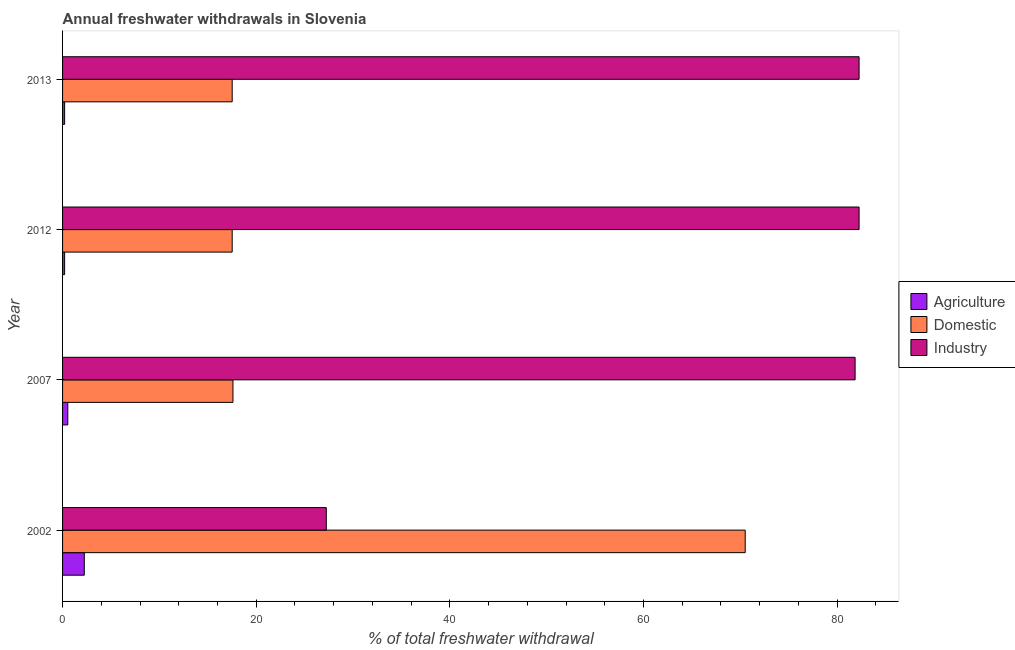How many groups of bars are there?
Offer a terse response. 4. Are the number of bars on each tick of the Y-axis equal?
Offer a very short reply. Yes. How many bars are there on the 3rd tick from the top?
Give a very brief answer. 3. What is the label of the 4th group of bars from the top?
Ensure brevity in your answer.  2002. In how many cases, is the number of bars for a given year not equal to the number of legend labels?
Your response must be concise. 0. What is the percentage of freshwater withdrawal for agriculture in 2013?
Ensure brevity in your answer.  0.21. Across all years, what is the maximum percentage of freshwater withdrawal for agriculture?
Make the answer very short. 2.24. Across all years, what is the minimum percentage of freshwater withdrawal for agriculture?
Offer a terse response. 0.21. In which year was the percentage of freshwater withdrawal for industry minimum?
Make the answer very short. 2002. What is the total percentage of freshwater withdrawal for domestic purposes in the graph?
Your answer should be compact. 123.15. What is the difference between the percentage of freshwater withdrawal for domestic purposes in 2002 and that in 2012?
Keep it short and to the point. 52.99. What is the difference between the percentage of freshwater withdrawal for domestic purposes in 2013 and the percentage of freshwater withdrawal for industry in 2012?
Keep it short and to the point. -64.75. What is the average percentage of freshwater withdrawal for agriculture per year?
Keep it short and to the point. 0.8. In the year 2002, what is the difference between the percentage of freshwater withdrawal for domestic purposes and percentage of freshwater withdrawal for industry?
Your answer should be very brief. 43.27. In how many years, is the percentage of freshwater withdrawal for agriculture greater than 20 %?
Keep it short and to the point. 0. What is the ratio of the percentage of freshwater withdrawal for agriculture in 2002 to that in 2012?
Your response must be concise. 10.57. What is the difference between the highest and the second highest percentage of freshwater withdrawal for domestic purposes?
Ensure brevity in your answer.  52.91. What is the difference between the highest and the lowest percentage of freshwater withdrawal for industry?
Offer a terse response. 55.03. In how many years, is the percentage of freshwater withdrawal for industry greater than the average percentage of freshwater withdrawal for industry taken over all years?
Keep it short and to the point. 3. Is the sum of the percentage of freshwater withdrawal for agriculture in 2007 and 2013 greater than the maximum percentage of freshwater withdrawal for industry across all years?
Provide a short and direct response. No. What does the 2nd bar from the top in 2013 represents?
Give a very brief answer. Domestic. What does the 1st bar from the bottom in 2013 represents?
Your answer should be compact. Agriculture. What is the difference between two consecutive major ticks on the X-axis?
Offer a terse response. 20. Are the values on the major ticks of X-axis written in scientific E-notation?
Your answer should be compact. No. Does the graph contain any zero values?
Offer a terse response. No. How are the legend labels stacked?
Your answer should be compact. Vertical. What is the title of the graph?
Ensure brevity in your answer.  Annual freshwater withdrawals in Slovenia. What is the label or title of the X-axis?
Your response must be concise. % of total freshwater withdrawal. What is the label or title of the Y-axis?
Give a very brief answer. Year. What is the % of total freshwater withdrawal in Agriculture in 2002?
Provide a short and direct response. 2.24. What is the % of total freshwater withdrawal in Domestic in 2002?
Ensure brevity in your answer.  70.51. What is the % of total freshwater withdrawal in Industry in 2002?
Keep it short and to the point. 27.24. What is the % of total freshwater withdrawal in Agriculture in 2007?
Your answer should be very brief. 0.54. What is the % of total freshwater withdrawal in Industry in 2007?
Your response must be concise. 81.86. What is the % of total freshwater withdrawal in Agriculture in 2012?
Make the answer very short. 0.21. What is the % of total freshwater withdrawal in Domestic in 2012?
Provide a succinct answer. 17.52. What is the % of total freshwater withdrawal in Industry in 2012?
Your answer should be very brief. 82.27. What is the % of total freshwater withdrawal in Agriculture in 2013?
Provide a succinct answer. 0.21. What is the % of total freshwater withdrawal of Domestic in 2013?
Offer a terse response. 17.52. What is the % of total freshwater withdrawal in Industry in 2013?
Keep it short and to the point. 82.27. Across all years, what is the maximum % of total freshwater withdrawal of Agriculture?
Provide a short and direct response. 2.24. Across all years, what is the maximum % of total freshwater withdrawal of Domestic?
Offer a terse response. 70.51. Across all years, what is the maximum % of total freshwater withdrawal of Industry?
Provide a short and direct response. 82.27. Across all years, what is the minimum % of total freshwater withdrawal of Agriculture?
Provide a succinct answer. 0.21. Across all years, what is the minimum % of total freshwater withdrawal of Domestic?
Provide a short and direct response. 17.52. Across all years, what is the minimum % of total freshwater withdrawal of Industry?
Give a very brief answer. 27.24. What is the total % of total freshwater withdrawal of Agriculture in the graph?
Offer a very short reply. 3.21. What is the total % of total freshwater withdrawal of Domestic in the graph?
Your response must be concise. 123.15. What is the total % of total freshwater withdrawal of Industry in the graph?
Offer a terse response. 273.64. What is the difference between the % of total freshwater withdrawal in Agriculture in 2002 and that in 2007?
Your response must be concise. 1.7. What is the difference between the % of total freshwater withdrawal in Domestic in 2002 and that in 2007?
Keep it short and to the point. 52.91. What is the difference between the % of total freshwater withdrawal in Industry in 2002 and that in 2007?
Make the answer very short. -54.62. What is the difference between the % of total freshwater withdrawal in Agriculture in 2002 and that in 2012?
Make the answer very short. 2.03. What is the difference between the % of total freshwater withdrawal in Domestic in 2002 and that in 2012?
Provide a short and direct response. 52.99. What is the difference between the % of total freshwater withdrawal of Industry in 2002 and that in 2012?
Offer a very short reply. -55.03. What is the difference between the % of total freshwater withdrawal of Agriculture in 2002 and that in 2013?
Ensure brevity in your answer.  2.03. What is the difference between the % of total freshwater withdrawal of Domestic in 2002 and that in 2013?
Ensure brevity in your answer.  52.99. What is the difference between the % of total freshwater withdrawal of Industry in 2002 and that in 2013?
Keep it short and to the point. -55.03. What is the difference between the % of total freshwater withdrawal of Agriculture in 2007 and that in 2012?
Ensure brevity in your answer.  0.33. What is the difference between the % of total freshwater withdrawal of Industry in 2007 and that in 2012?
Ensure brevity in your answer.  -0.41. What is the difference between the % of total freshwater withdrawal in Agriculture in 2007 and that in 2013?
Your response must be concise. 0.33. What is the difference between the % of total freshwater withdrawal of Industry in 2007 and that in 2013?
Your response must be concise. -0.41. What is the difference between the % of total freshwater withdrawal of Agriculture in 2012 and that in 2013?
Your response must be concise. 0. What is the difference between the % of total freshwater withdrawal in Industry in 2012 and that in 2013?
Your response must be concise. 0. What is the difference between the % of total freshwater withdrawal of Agriculture in 2002 and the % of total freshwater withdrawal of Domestic in 2007?
Provide a short and direct response. -15.36. What is the difference between the % of total freshwater withdrawal in Agriculture in 2002 and the % of total freshwater withdrawal in Industry in 2007?
Keep it short and to the point. -79.62. What is the difference between the % of total freshwater withdrawal of Domestic in 2002 and the % of total freshwater withdrawal of Industry in 2007?
Provide a short and direct response. -11.35. What is the difference between the % of total freshwater withdrawal in Agriculture in 2002 and the % of total freshwater withdrawal in Domestic in 2012?
Give a very brief answer. -15.28. What is the difference between the % of total freshwater withdrawal of Agriculture in 2002 and the % of total freshwater withdrawal of Industry in 2012?
Keep it short and to the point. -80.03. What is the difference between the % of total freshwater withdrawal of Domestic in 2002 and the % of total freshwater withdrawal of Industry in 2012?
Ensure brevity in your answer.  -11.76. What is the difference between the % of total freshwater withdrawal in Agriculture in 2002 and the % of total freshwater withdrawal in Domestic in 2013?
Provide a succinct answer. -15.28. What is the difference between the % of total freshwater withdrawal of Agriculture in 2002 and the % of total freshwater withdrawal of Industry in 2013?
Keep it short and to the point. -80.03. What is the difference between the % of total freshwater withdrawal of Domestic in 2002 and the % of total freshwater withdrawal of Industry in 2013?
Your response must be concise. -11.76. What is the difference between the % of total freshwater withdrawal of Agriculture in 2007 and the % of total freshwater withdrawal of Domestic in 2012?
Your answer should be very brief. -16.98. What is the difference between the % of total freshwater withdrawal of Agriculture in 2007 and the % of total freshwater withdrawal of Industry in 2012?
Your answer should be very brief. -81.73. What is the difference between the % of total freshwater withdrawal of Domestic in 2007 and the % of total freshwater withdrawal of Industry in 2012?
Your response must be concise. -64.67. What is the difference between the % of total freshwater withdrawal in Agriculture in 2007 and the % of total freshwater withdrawal in Domestic in 2013?
Offer a terse response. -16.98. What is the difference between the % of total freshwater withdrawal in Agriculture in 2007 and the % of total freshwater withdrawal in Industry in 2013?
Offer a terse response. -81.73. What is the difference between the % of total freshwater withdrawal of Domestic in 2007 and the % of total freshwater withdrawal of Industry in 2013?
Your response must be concise. -64.67. What is the difference between the % of total freshwater withdrawal in Agriculture in 2012 and the % of total freshwater withdrawal in Domestic in 2013?
Ensure brevity in your answer.  -17.31. What is the difference between the % of total freshwater withdrawal in Agriculture in 2012 and the % of total freshwater withdrawal in Industry in 2013?
Make the answer very short. -82.06. What is the difference between the % of total freshwater withdrawal of Domestic in 2012 and the % of total freshwater withdrawal of Industry in 2013?
Your answer should be very brief. -64.75. What is the average % of total freshwater withdrawal of Agriculture per year?
Keep it short and to the point. 0.8. What is the average % of total freshwater withdrawal in Domestic per year?
Offer a terse response. 30.79. What is the average % of total freshwater withdrawal in Industry per year?
Your answer should be very brief. 68.41. In the year 2002, what is the difference between the % of total freshwater withdrawal of Agriculture and % of total freshwater withdrawal of Domestic?
Provide a succinct answer. -68.27. In the year 2002, what is the difference between the % of total freshwater withdrawal of Agriculture and % of total freshwater withdrawal of Industry?
Keep it short and to the point. -25. In the year 2002, what is the difference between the % of total freshwater withdrawal in Domestic and % of total freshwater withdrawal in Industry?
Provide a short and direct response. 43.27. In the year 2007, what is the difference between the % of total freshwater withdrawal of Agriculture and % of total freshwater withdrawal of Domestic?
Provide a short and direct response. -17.06. In the year 2007, what is the difference between the % of total freshwater withdrawal of Agriculture and % of total freshwater withdrawal of Industry?
Your response must be concise. -81.32. In the year 2007, what is the difference between the % of total freshwater withdrawal of Domestic and % of total freshwater withdrawal of Industry?
Make the answer very short. -64.26. In the year 2012, what is the difference between the % of total freshwater withdrawal in Agriculture and % of total freshwater withdrawal in Domestic?
Provide a short and direct response. -17.31. In the year 2012, what is the difference between the % of total freshwater withdrawal of Agriculture and % of total freshwater withdrawal of Industry?
Ensure brevity in your answer.  -82.06. In the year 2012, what is the difference between the % of total freshwater withdrawal in Domestic and % of total freshwater withdrawal in Industry?
Your response must be concise. -64.75. In the year 2013, what is the difference between the % of total freshwater withdrawal of Agriculture and % of total freshwater withdrawal of Domestic?
Ensure brevity in your answer.  -17.31. In the year 2013, what is the difference between the % of total freshwater withdrawal of Agriculture and % of total freshwater withdrawal of Industry?
Give a very brief answer. -82.06. In the year 2013, what is the difference between the % of total freshwater withdrawal in Domestic and % of total freshwater withdrawal in Industry?
Provide a succinct answer. -64.75. What is the ratio of the % of total freshwater withdrawal of Agriculture in 2002 to that in 2007?
Offer a terse response. 4.16. What is the ratio of the % of total freshwater withdrawal of Domestic in 2002 to that in 2007?
Provide a succinct answer. 4.01. What is the ratio of the % of total freshwater withdrawal of Industry in 2002 to that in 2007?
Give a very brief answer. 0.33. What is the ratio of the % of total freshwater withdrawal of Agriculture in 2002 to that in 2012?
Ensure brevity in your answer.  10.57. What is the ratio of the % of total freshwater withdrawal in Domestic in 2002 to that in 2012?
Make the answer very short. 4.02. What is the ratio of the % of total freshwater withdrawal in Industry in 2002 to that in 2012?
Your answer should be very brief. 0.33. What is the ratio of the % of total freshwater withdrawal of Agriculture in 2002 to that in 2013?
Offer a terse response. 10.57. What is the ratio of the % of total freshwater withdrawal of Domestic in 2002 to that in 2013?
Offer a very short reply. 4.02. What is the ratio of the % of total freshwater withdrawal of Industry in 2002 to that in 2013?
Your answer should be compact. 0.33. What is the ratio of the % of total freshwater withdrawal in Agriculture in 2007 to that in 2012?
Offer a terse response. 2.54. What is the ratio of the % of total freshwater withdrawal of Agriculture in 2007 to that in 2013?
Your answer should be compact. 2.54. What is the ratio of the % of total freshwater withdrawal of Industry in 2007 to that in 2013?
Provide a short and direct response. 0.99. What is the ratio of the % of total freshwater withdrawal in Domestic in 2012 to that in 2013?
Provide a succinct answer. 1. What is the difference between the highest and the second highest % of total freshwater withdrawal in Agriculture?
Ensure brevity in your answer.  1.7. What is the difference between the highest and the second highest % of total freshwater withdrawal of Domestic?
Your response must be concise. 52.91. What is the difference between the highest and the second highest % of total freshwater withdrawal of Industry?
Your answer should be compact. 0. What is the difference between the highest and the lowest % of total freshwater withdrawal of Agriculture?
Your answer should be compact. 2.03. What is the difference between the highest and the lowest % of total freshwater withdrawal of Domestic?
Offer a terse response. 52.99. What is the difference between the highest and the lowest % of total freshwater withdrawal in Industry?
Your answer should be very brief. 55.03. 